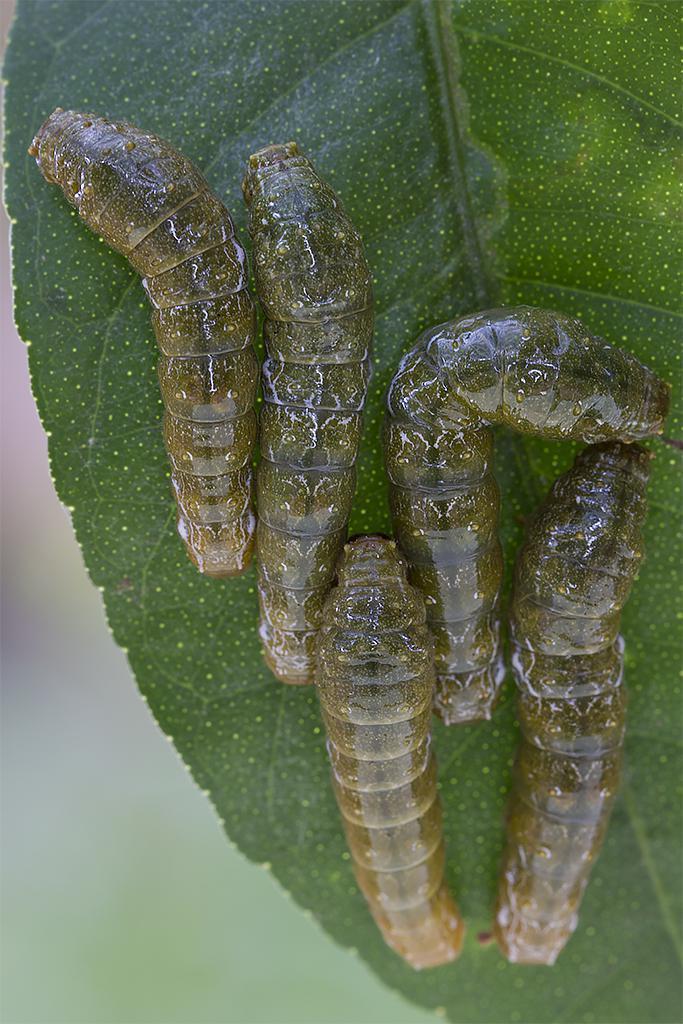How would you summarize this image in a sentence or two? In this image I can see caterpillars on a leaf. The background of the image is blurred. 